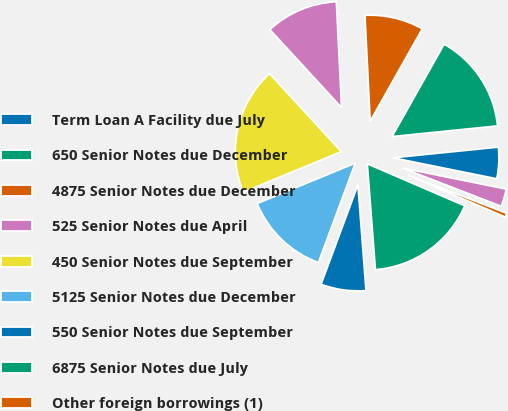Convert chart. <chart><loc_0><loc_0><loc_500><loc_500><pie_chart><fcel>Term Loan A Facility due July<fcel>650 Senior Notes due December<fcel>4875 Senior Notes due December<fcel>525 Senior Notes due April<fcel>450 Senior Notes due September<fcel>5125 Senior Notes due December<fcel>550 Senior Notes due September<fcel>6875 Senior Notes due July<fcel>Other foreign borrowings (1)<fcel>Other domestic borrowings<nl><fcel>4.78%<fcel>15.22%<fcel>8.96%<fcel>11.04%<fcel>19.39%<fcel>13.13%<fcel>6.87%<fcel>17.3%<fcel>0.61%<fcel>2.7%<nl></chart> 